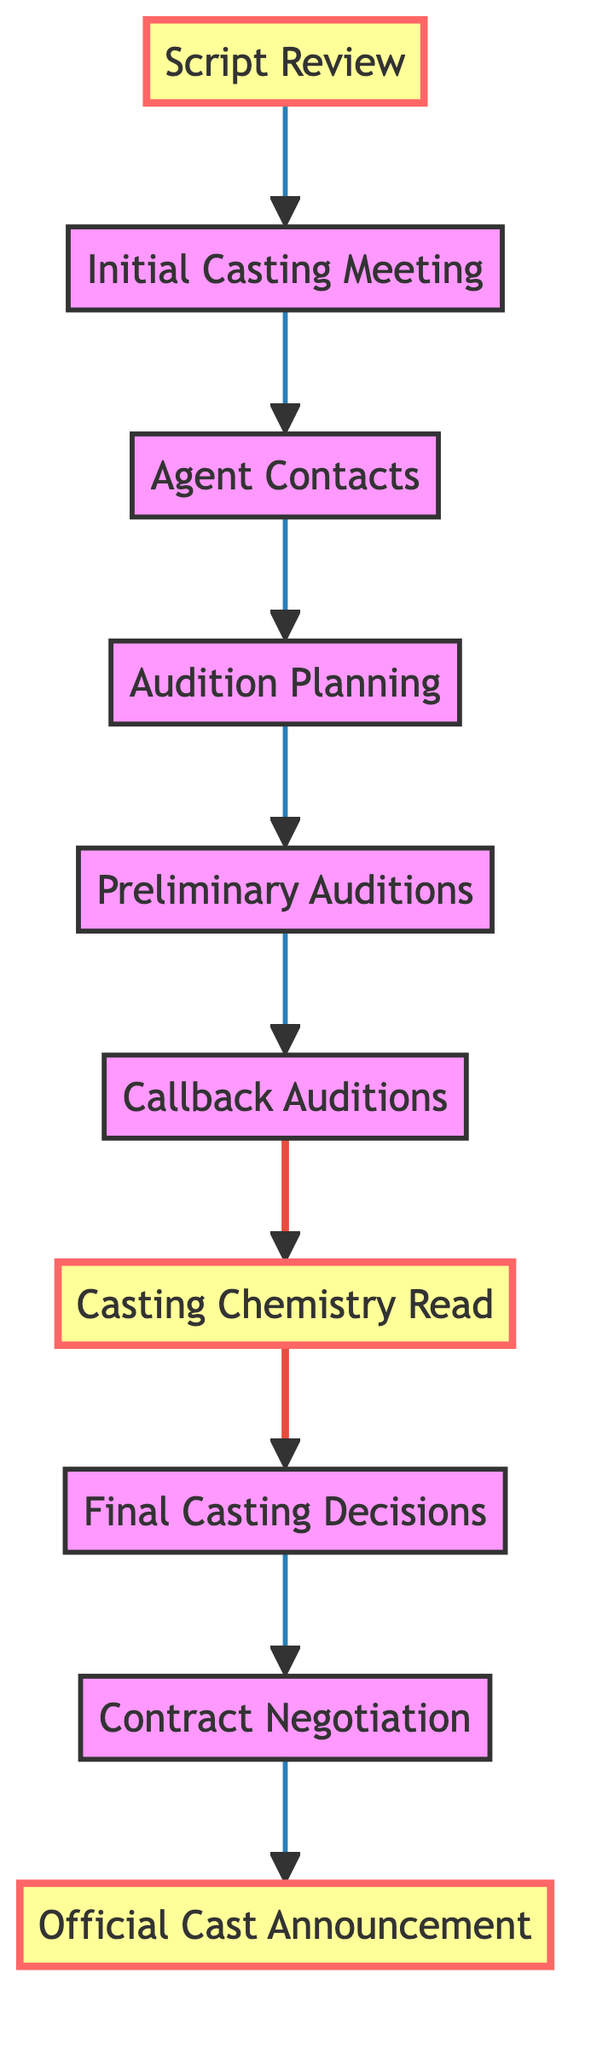What is the first step in the casting process? The diagram indicates that the first step is "Script Review." This is shown as the starting node labeled "Script Review."
Answer: Script Review How many total steps are there in the casting process? By counting the nodes in the diagram, there are ten steps listed sequentially.
Answer: Ten Which step directly follows "Preliminary Auditions"? Following the node labeled "Preliminary Auditions," the next step is "Callback Auditions." This connection is represented by a directed edge from "Preliminary Auditions" to "Callback Auditions."
Answer: Callback Auditions What is the last step before the official cast announcement? The node representing the step immediately prior to the "Official Cast Announcement" is "Contract Negotiation." The flow transitions from "Contract Negotiation" to "Official Cast Announcement."
Answer: Contract Negotiation What step involves Tye Sheridan testing on-screen dynamics? The step specifically dedicated to Tye Sheridan participating in chemistry reads is labeled "Casting Chemistry Read." It is a distinct node connected after "Callback Auditions."
Answer: Casting Chemistry Read How many steps are highlighted in the diagram? There are three highlighted steps in the flow chart: "Script Review," "Casting Chemistry Read," and "Official Cast Announcement." Counting these highlighted nodes shows a total of three.
Answer: Three Which roles are discussed in the "Initial Casting Meeting"? During the "Initial Casting Meeting," the director discusses key roles and potential actors. This is summarized in the description associated with the "Initial Casting Meeting" node in the diagram.
Answer: Key roles What is the goal of the "Audition Planning" step? The "Audition Planning" step aims to schedule and plan auditions for supporting roles while ensuring coordination with Tye Sheridan's availability. This goal is articulated in the step's description.
Answer: Schedule auditions What happens after the "Callback Auditions"? After "Callback Auditions," the next process in the flow is "Casting Chemistry Read," where Tye Sheridan engages in testing chemistry with co-stars. This is a continuation from the callback phase.
Answer: Casting Chemistry Read 